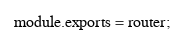Convert code to text. <code><loc_0><loc_0><loc_500><loc_500><_JavaScript_>
module.exports = router;
</code> 